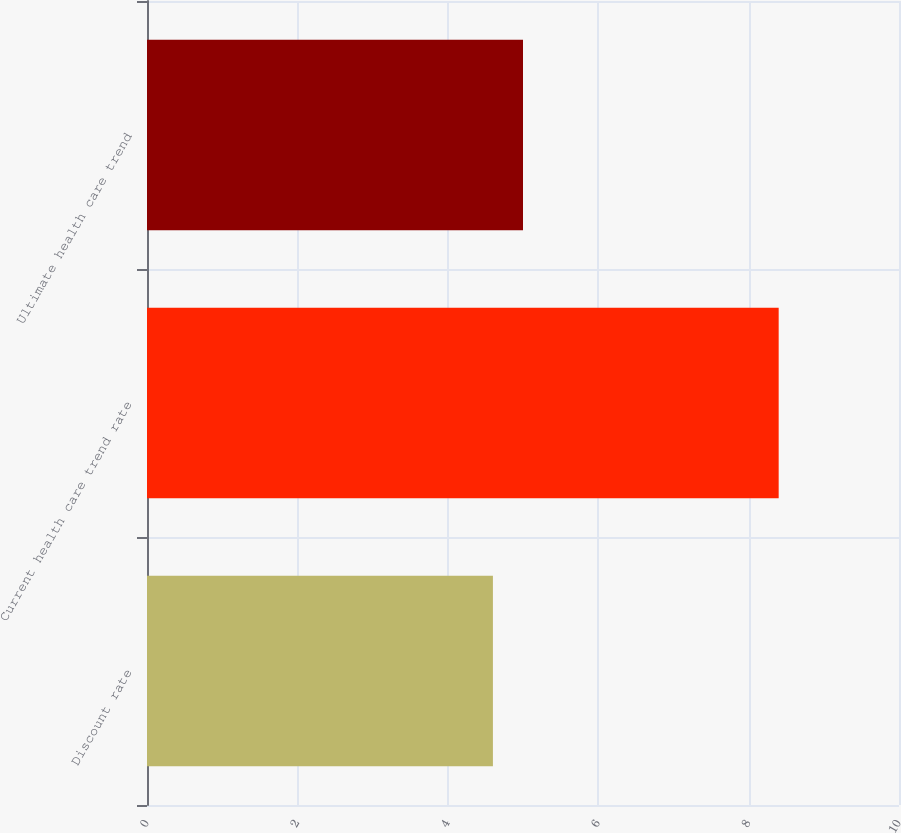Convert chart to OTSL. <chart><loc_0><loc_0><loc_500><loc_500><bar_chart><fcel>Discount rate<fcel>Current health care trend rate<fcel>Ultimate health care trend<nl><fcel>4.6<fcel>8.4<fcel>5<nl></chart> 